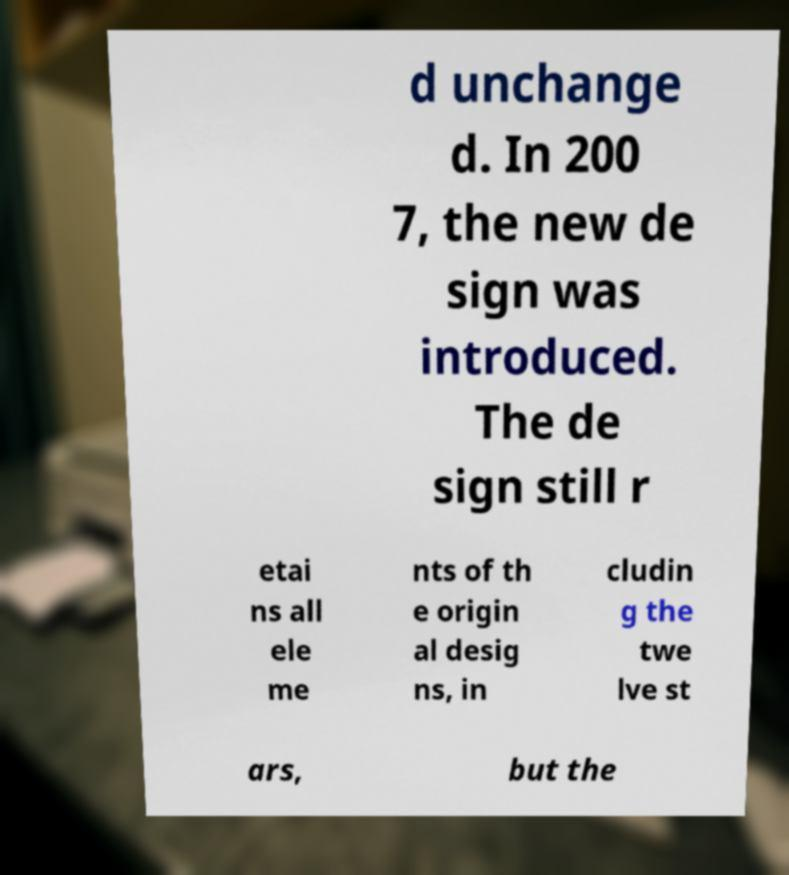There's text embedded in this image that I need extracted. Can you transcribe it verbatim? d unchange d. In 200 7, the new de sign was introduced. The de sign still r etai ns all ele me nts of th e origin al desig ns, in cludin g the twe lve st ars, but the 